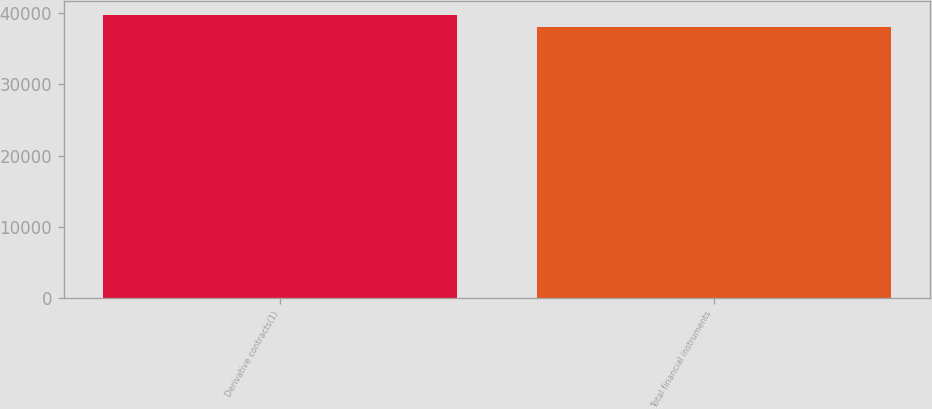<chart> <loc_0><loc_0><loc_500><loc_500><bar_chart><fcel>Derivative contracts(1)<fcel>Total financial instruments<nl><fcel>39778<fcel>38058<nl></chart> 